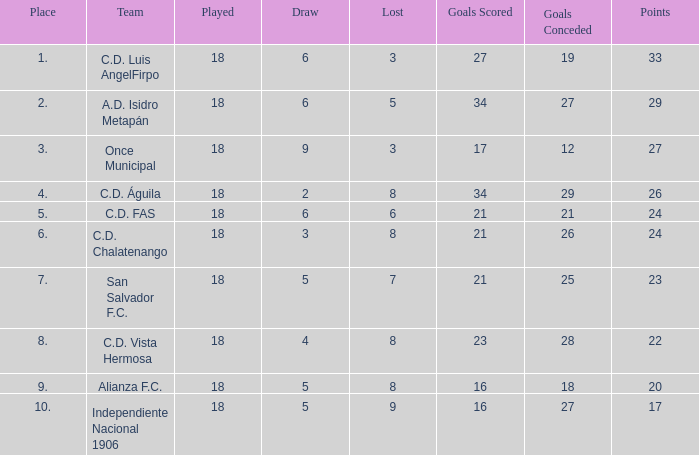What is the total number of points in a match with 5 losses, a position higher than 2nd, and 27 goals given up? 0.0. 